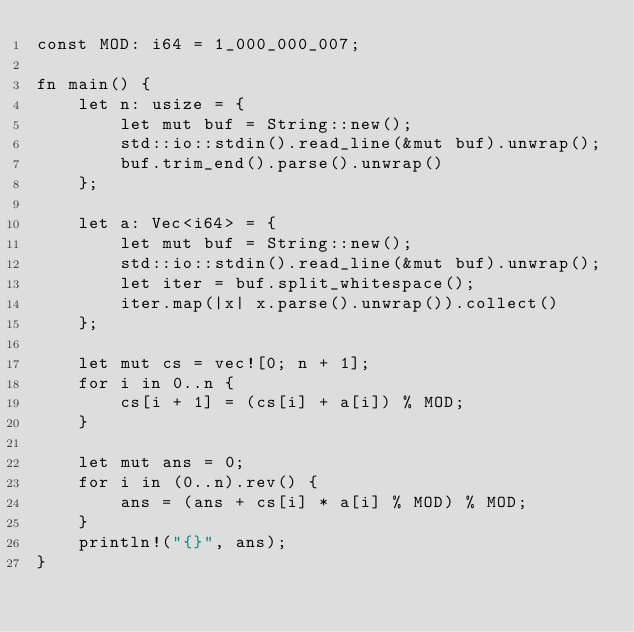Convert code to text. <code><loc_0><loc_0><loc_500><loc_500><_Rust_>const MOD: i64 = 1_000_000_007;

fn main() {
    let n: usize = {
        let mut buf = String::new();
        std::io::stdin().read_line(&mut buf).unwrap();
        buf.trim_end().parse().unwrap()
    };

    let a: Vec<i64> = {
        let mut buf = String::new();
        std::io::stdin().read_line(&mut buf).unwrap();
        let iter = buf.split_whitespace();
        iter.map(|x| x.parse().unwrap()).collect()
    };

    let mut cs = vec![0; n + 1];
    for i in 0..n {
        cs[i + 1] = (cs[i] + a[i]) % MOD;
    }

    let mut ans = 0;
    for i in (0..n).rev() {
        ans = (ans + cs[i] * a[i] % MOD) % MOD;
    }
    println!("{}", ans);
}</code> 